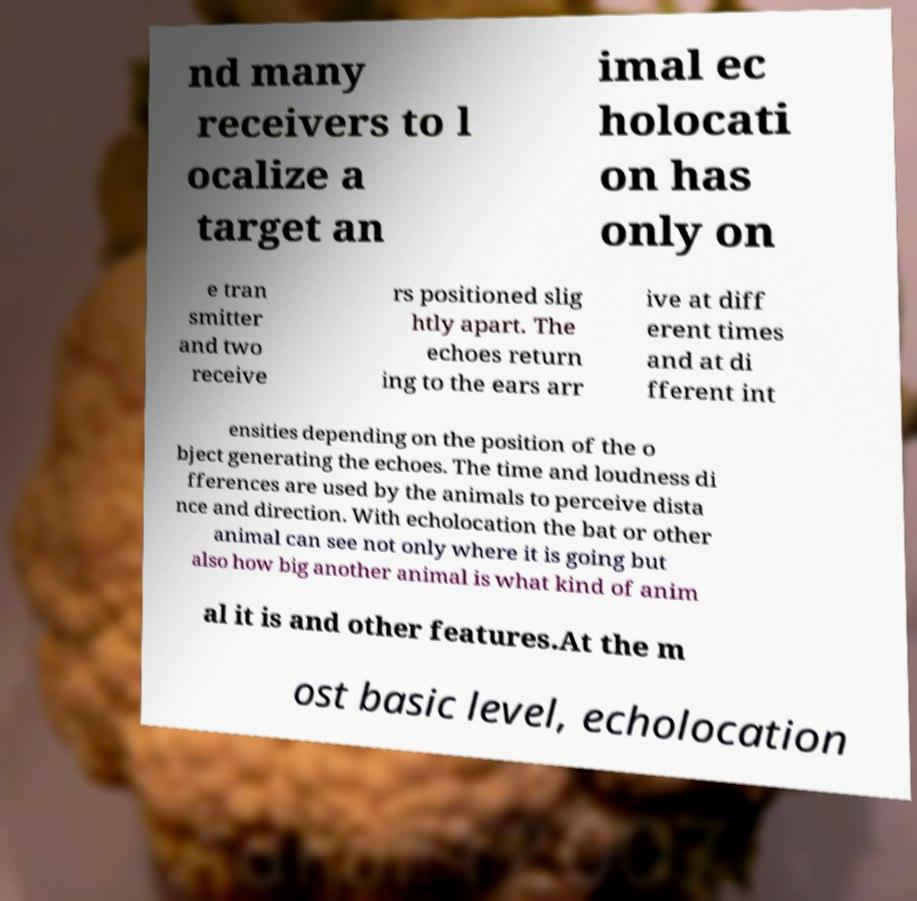Could you assist in decoding the text presented in this image and type it out clearly? nd many receivers to l ocalize a target an imal ec holocati on has only on e tran smitter and two receive rs positioned slig htly apart. The echoes return ing to the ears arr ive at diff erent times and at di fferent int ensities depending on the position of the o bject generating the echoes. The time and loudness di fferences are used by the animals to perceive dista nce and direction. With echolocation the bat or other animal can see not only where it is going but also how big another animal is what kind of anim al it is and other features.At the m ost basic level, echolocation 